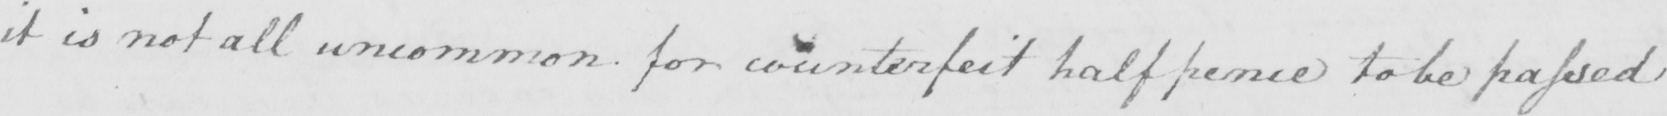Can you tell me what this handwritten text says? it is not all uncommon for counterfeit halfpence to be passed 